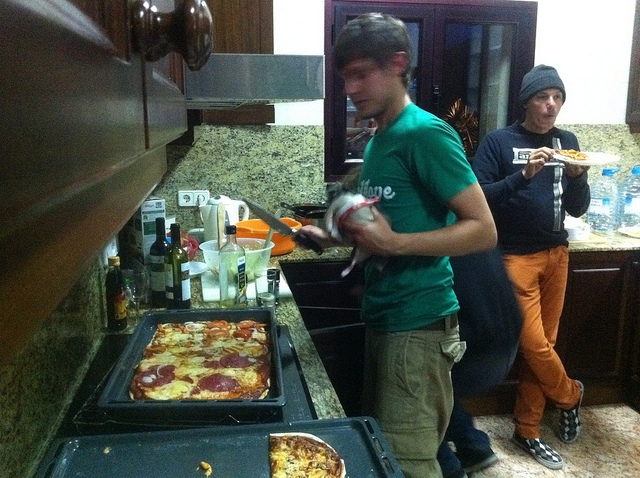Extract all visible text content from this image. Love 